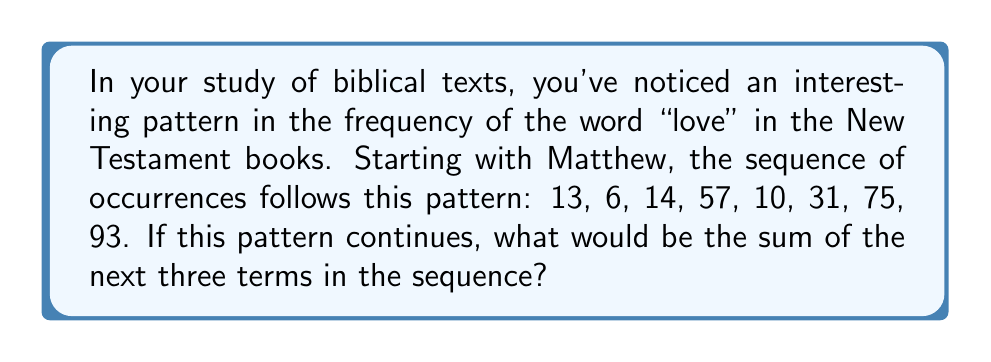Teach me how to tackle this problem. To solve this problem, we need to analyze the given sequence and identify the pattern. Let's approach this step-by-step:

1) Given sequence: 13, 6, 14, 57, 10, 31, 75, 93

2) Let's look at the differences between consecutive terms:
   $13 \rightarrow 6$ : -7
   $6 \rightarrow 14$ : +8
   $14 \rightarrow 57$ : +43
   $57 \rightarrow 10$ : -47
   $10 \rightarrow 31$ : +21
   $31 \rightarrow 75$ : +44
   $75 \rightarrow 93$ : +18

3) We can observe that the pattern alternates between addition and subtraction:
   +8, +43, +21, +44 (additions)
   -7, -47 (subtractions)

4) The additions seem to follow the pattern: +8, +43, +21, +44, ...
   We can see that it's increasing by 35, then decreasing by 22, then increasing by 23.

5) The subtractions seem to follow: -7, -47, ...
   We can see that it's decreasing by 40.

6) Therefore, the next three terms would be:
   93 - 87 = 6 (subtracting 87, which is 47 + 40)
   6 + 29 = 35 (adding 29, which is 44 - 15)
   35 + 64 = 99 (adding 64, which is 29 + 35)

7) The sum of these three terms:
   $6 + 35 + 99 = 140$
Answer: 140 